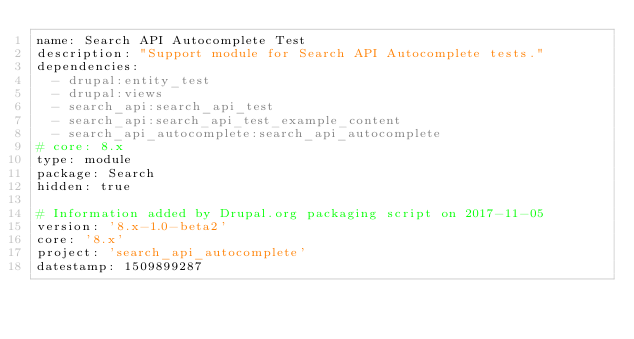Convert code to text. <code><loc_0><loc_0><loc_500><loc_500><_YAML_>name: Search API Autocomplete Test
description: "Support module for Search API Autocomplete tests."
dependencies:
  - drupal:entity_test
  - drupal:views
  - search_api:search_api_test
  - search_api:search_api_test_example_content
  - search_api_autocomplete:search_api_autocomplete
# core: 8.x
type: module
package: Search
hidden: true

# Information added by Drupal.org packaging script on 2017-11-05
version: '8.x-1.0-beta2'
core: '8.x'
project: 'search_api_autocomplete'
datestamp: 1509899287
</code> 